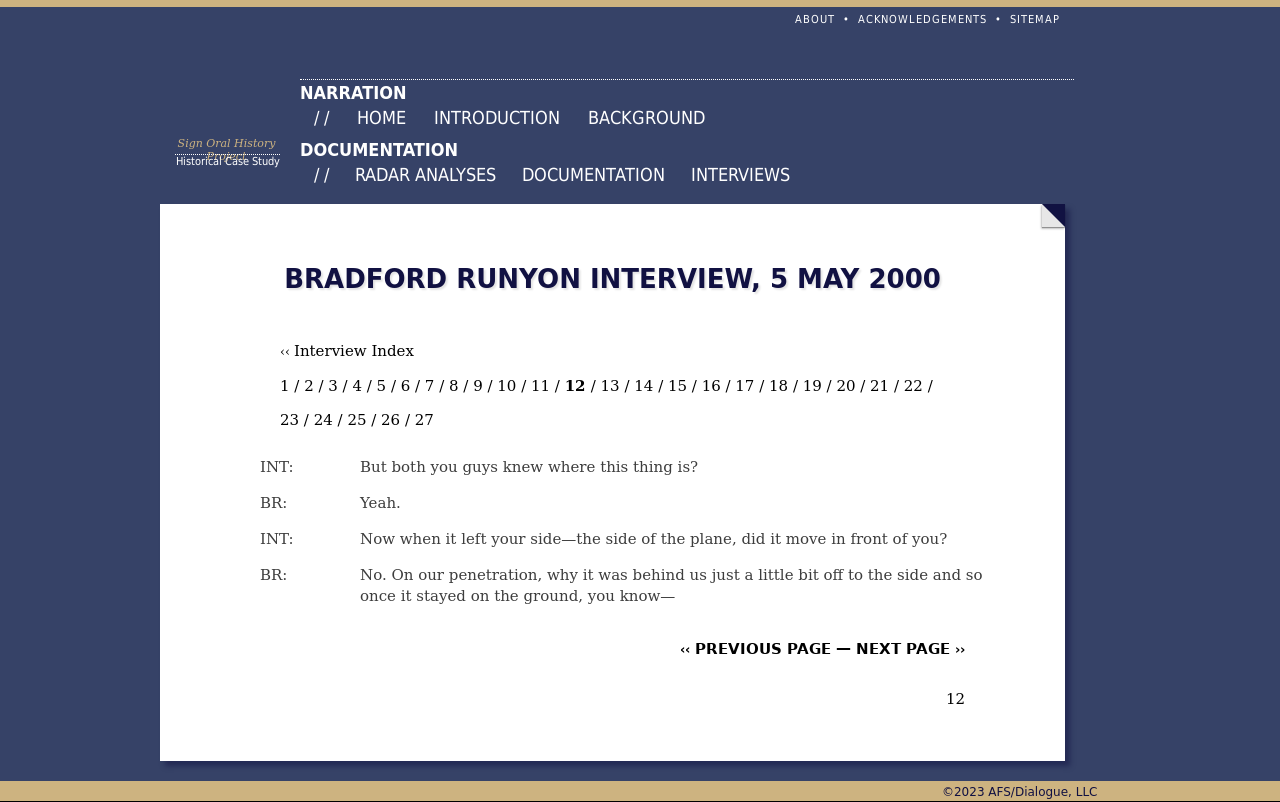What's the procedure for constructing this website from scratch with HTML? The image shows a simple web page that contains text from an interview. This could be constructed using HTML and CSS for layout and formatting. A basic version of such a page can be built by using HTML tags like <!DOCTYPE html>, <html>, <head>, and <body>. Inside the body, use <div> elements to create sections like headers, navigation bars, and the content area where the interview text resides. Style the page using CSS to define fonts, colors, and alignment, reflecting the structure and design as shown in the image. 